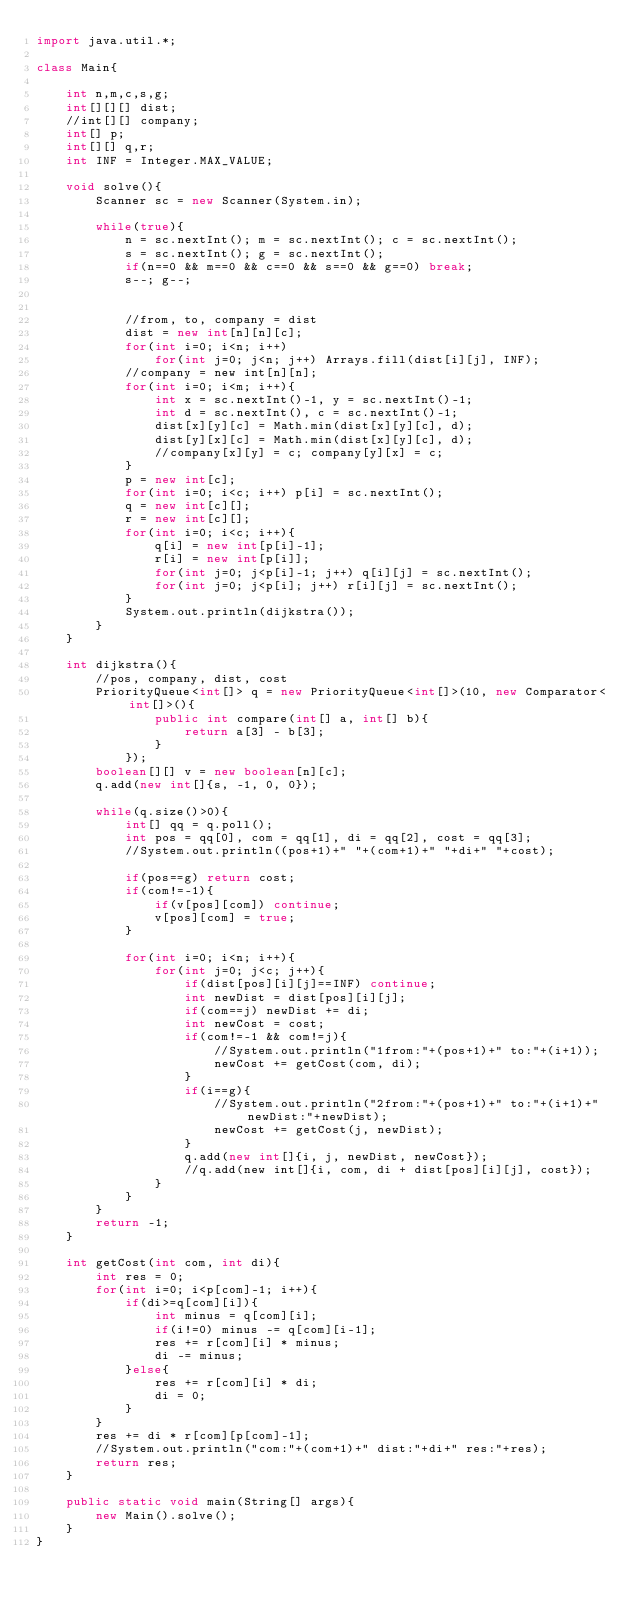<code> <loc_0><loc_0><loc_500><loc_500><_Java_>import java.util.*;

class Main{

    int n,m,c,s,g;
    int[][][] dist;
    //int[][] company;
    int[] p;
    int[][] q,r;
    int INF = Integer.MAX_VALUE;

    void solve(){
        Scanner sc = new Scanner(System.in);

        while(true){
            n = sc.nextInt(); m = sc.nextInt(); c = sc.nextInt();
            s = sc.nextInt(); g = sc.nextInt();
            if(n==0 && m==0 && c==0 && s==0 && g==0) break;
            s--; g--;


            //from, to, company = dist
            dist = new int[n][n][c];
            for(int i=0; i<n; i++) 
                for(int j=0; j<n; j++) Arrays.fill(dist[i][j], INF);
            //company = new int[n][n];
            for(int i=0; i<m; i++){
                int x = sc.nextInt()-1, y = sc.nextInt()-1;
                int d = sc.nextInt(), c = sc.nextInt()-1;
                dist[x][y][c] = Math.min(dist[x][y][c], d); 
                dist[y][x][c] = Math.min(dist[x][y][c], d);
                //company[x][y] = c; company[y][x] = c;
            }
            p = new int[c];
            for(int i=0; i<c; i++) p[i] = sc.nextInt();
            q = new int[c][];
            r = new int[c][];
            for(int i=0; i<c; i++){
                q[i] = new int[p[i]-1];
                r[i] = new int[p[i]];
                for(int j=0; j<p[i]-1; j++) q[i][j] = sc.nextInt();
                for(int j=0; j<p[i]; j++) r[i][j] = sc.nextInt();
            }
            System.out.println(dijkstra());
        }
    }

    int dijkstra(){
        //pos, company, dist, cost
        PriorityQueue<int[]> q = new PriorityQueue<int[]>(10, new Comparator<int[]>(){
                public int compare(int[] a, int[] b){
                    return a[3] - b[3];
                }
            });
        boolean[][] v = new boolean[n][c];
        q.add(new int[]{s, -1, 0, 0});

        while(q.size()>0){
            int[] qq = q.poll();
            int pos = qq[0], com = qq[1], di = qq[2], cost = qq[3];
            //System.out.println((pos+1)+" "+(com+1)+" "+di+" "+cost);

            if(pos==g) return cost;
            if(com!=-1){
                if(v[pos][com]) continue;
                v[pos][com] = true;
            }

            for(int i=0; i<n; i++){
                for(int j=0; j<c; j++){
                    if(dist[pos][i][j]==INF) continue;
                    int newDist = dist[pos][i][j];
                    if(com==j) newDist += di;
                    int newCost = cost;
                    if(com!=-1 && com!=j){
                        //System.out.println("1from:"+(pos+1)+" to:"+(i+1));
                        newCost += getCost(com, di);
                    }
                    if(i==g){
                        //System.out.println("2from:"+(pos+1)+" to:"+(i+1)+" newDist:"+newDist);
                        newCost += getCost(j, newDist);
                    }
                    q.add(new int[]{i, j, newDist, newCost});
                    //q.add(new int[]{i, com, di + dist[pos][i][j], cost});
                }
            }
        }
        return -1;
    }

    int getCost(int com, int di){
        int res = 0;
        for(int i=0; i<p[com]-1; i++){
            if(di>=q[com][i]){
                int minus = q[com][i];
                if(i!=0) minus -= q[com][i-1];
                res += r[com][i] * minus;
                di -= minus;
            }else{
                res += r[com][i] * di;
                di = 0;
            }
        }
        res += di * r[com][p[com]-1];
        //System.out.println("com:"+(com+1)+" dist:"+di+" res:"+res);
        return res;
    }

    public static void main(String[] args){
        new Main().solve();
    }
}</code> 